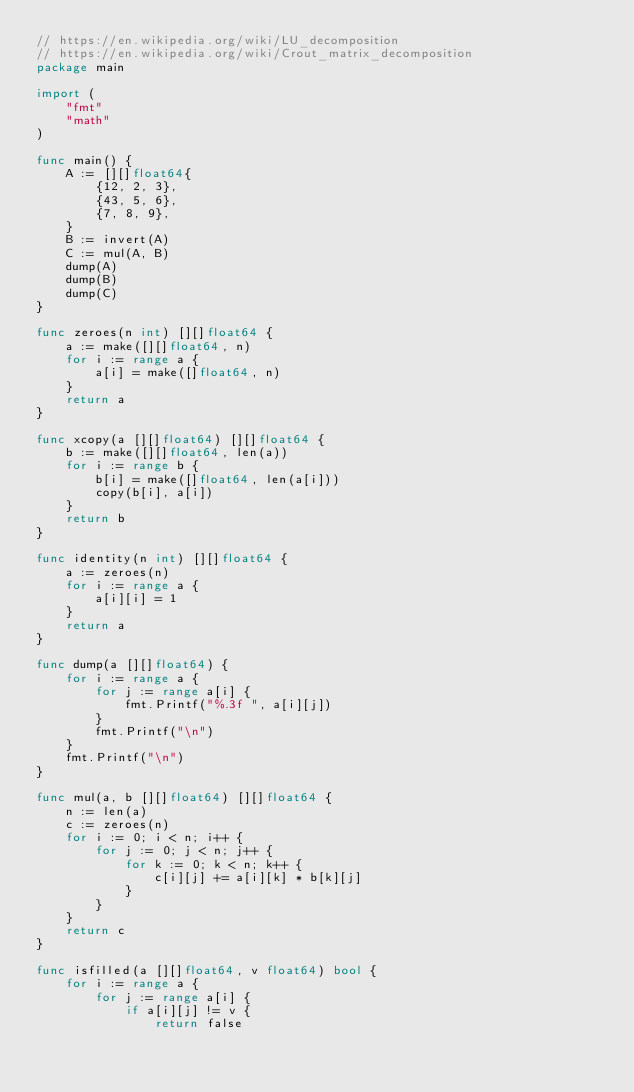Convert code to text. <code><loc_0><loc_0><loc_500><loc_500><_Go_>// https://en.wikipedia.org/wiki/LU_decomposition
// https://en.wikipedia.org/wiki/Crout_matrix_decomposition
package main

import (
	"fmt"
	"math"
)

func main() {
	A := [][]float64{
		{12, 2, 3},
		{43, 5, 6},
		{7, 8, 9},
	}
	B := invert(A)
	C := mul(A, B)
	dump(A)
	dump(B)
	dump(C)
}

func zeroes(n int) [][]float64 {
	a := make([][]float64, n)
	for i := range a {
		a[i] = make([]float64, n)
	}
	return a
}

func xcopy(a [][]float64) [][]float64 {
	b := make([][]float64, len(a))
	for i := range b {
		b[i] = make([]float64, len(a[i]))
		copy(b[i], a[i])
	}
	return b
}

func identity(n int) [][]float64 {
	a := zeroes(n)
	for i := range a {
		a[i][i] = 1
	}
	return a
}

func dump(a [][]float64) {
	for i := range a {
		for j := range a[i] {
			fmt.Printf("%.3f ", a[i][j])
		}
		fmt.Printf("\n")
	}
	fmt.Printf("\n")
}

func mul(a, b [][]float64) [][]float64 {
	n := len(a)
	c := zeroes(n)
	for i := 0; i < n; i++ {
		for j := 0; j < n; j++ {
			for k := 0; k < n; k++ {
				c[i][j] += a[i][k] * b[k][j]
			}
		}
	}
	return c
}

func isfilled(a [][]float64, v float64) bool {
	for i := range a {
		for j := range a[i] {
			if a[i][j] != v {
				return false</code> 